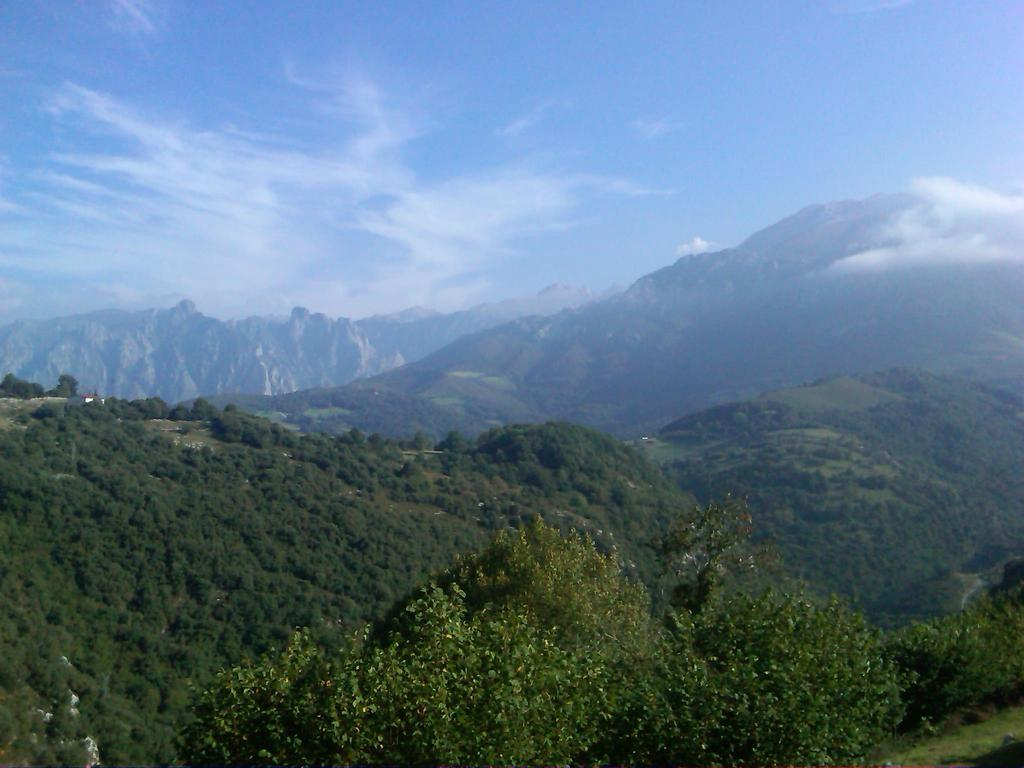Where was the picture taken? The picture was clicked outside. What can be seen in the foreground of the image? There are trees and green grass in the foreground of the image, along with some objects. What is visible in the background of the image? The sky and hills are visible in the background of the image. How many balls are visible in the image? There are no balls present in the image. What type of hope can be seen in the image? There is no representation of hope in the image; it is a photograph of an outdoor scene with trees, grass, objects, sky, and hills. 